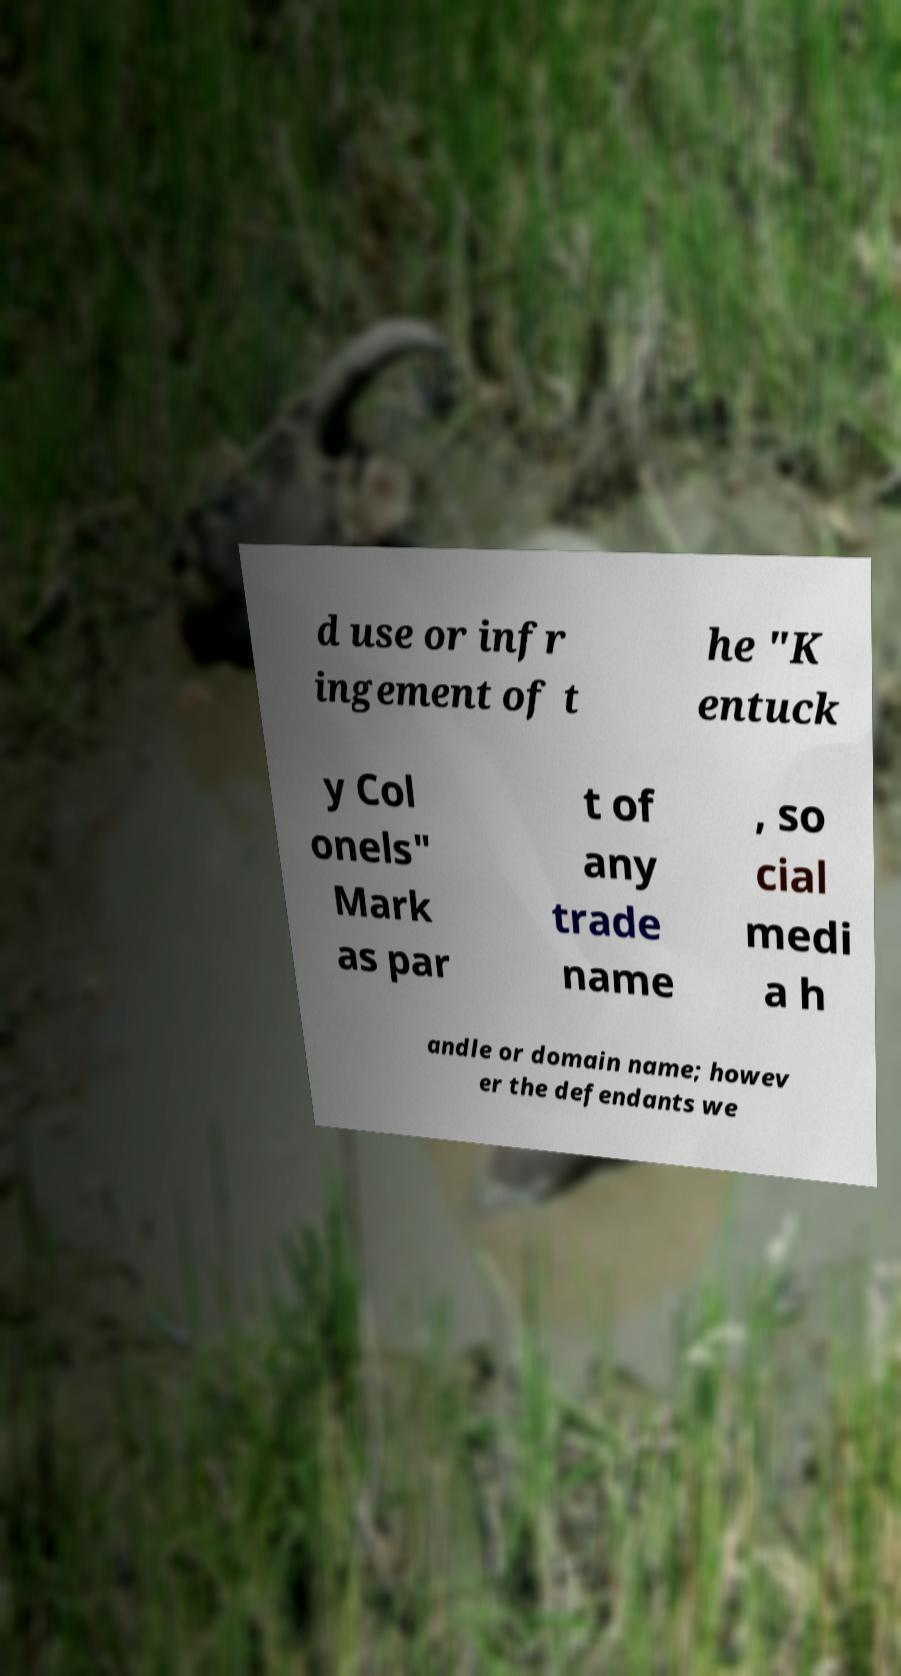Could you extract and type out the text from this image? d use or infr ingement of t he "K entuck y Col onels" Mark as par t of any trade name , so cial medi a h andle or domain name; howev er the defendants we 